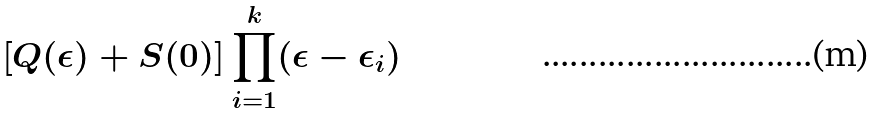Convert formula to latex. <formula><loc_0><loc_0><loc_500><loc_500>\left [ Q ( \epsilon ) + S ( 0 ) \right ] \prod _ { i = 1 } ^ { k } ( \epsilon - \epsilon _ { i } )</formula> 